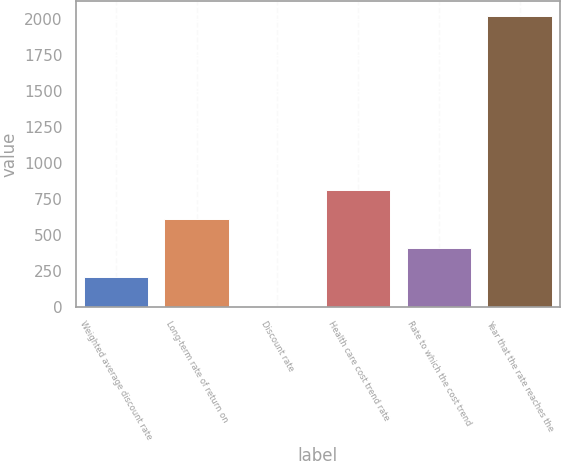Convert chart. <chart><loc_0><loc_0><loc_500><loc_500><bar_chart><fcel>Weighted average discount rate<fcel>Long-term rate of return on<fcel>Discount rate<fcel>Health care cost trend rate<fcel>Rate to which the cost trend<fcel>Year that the rate reaches the<nl><fcel>205.91<fcel>609.05<fcel>4.34<fcel>810.62<fcel>407.48<fcel>2020<nl></chart> 